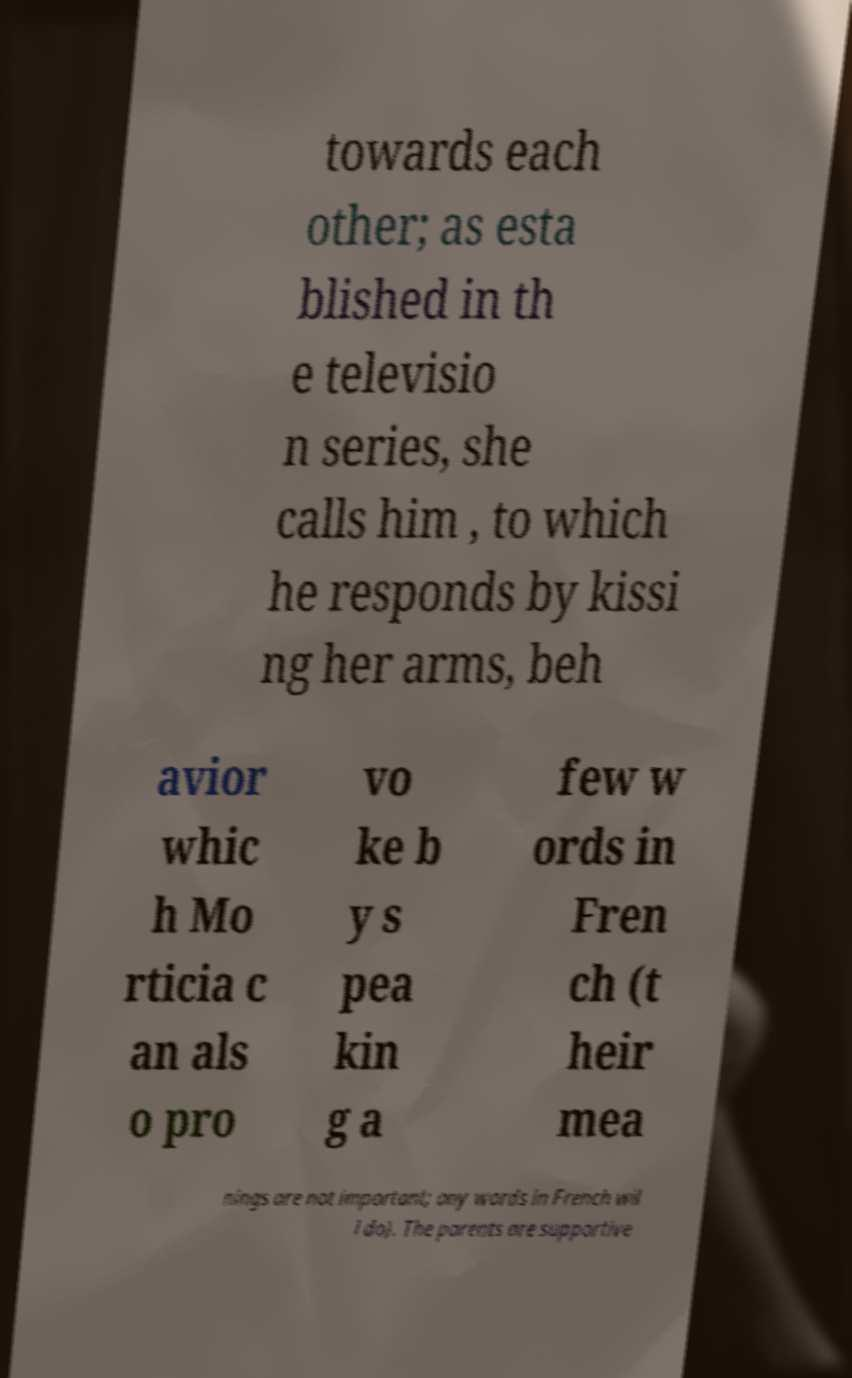Could you extract and type out the text from this image? towards each other; as esta blished in th e televisio n series, she calls him , to which he responds by kissi ng her arms, beh avior whic h Mo rticia c an als o pro vo ke b y s pea kin g a few w ords in Fren ch (t heir mea nings are not important; any words in French wil l do). The parents are supportive 